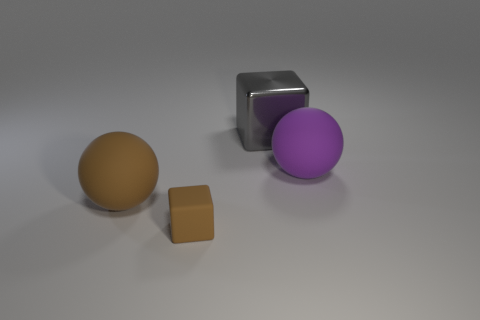Add 2 large purple rubber things. How many objects exist? 6 Add 2 tiny brown rubber cubes. How many tiny brown rubber cubes are left? 3 Add 2 gray spheres. How many gray spheres exist? 2 Subtract 0 red cubes. How many objects are left? 4 Subtract all small gray metallic cubes. Subtract all purple matte spheres. How many objects are left? 3 